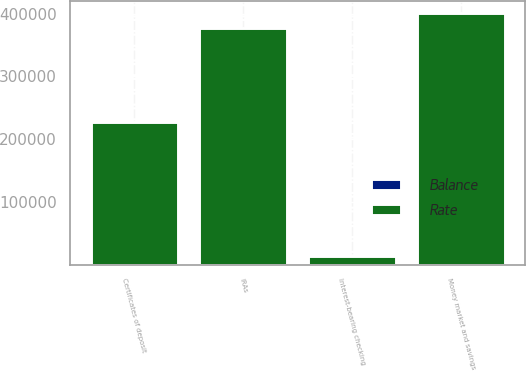<chart> <loc_0><loc_0><loc_500><loc_500><stacked_bar_chart><ecel><fcel>Money market and savings<fcel>Interest-bearing checking<fcel>IRAs<fcel>Certificates of deposit<nl><fcel>Rate<fcel>400920<fcel>13677<fcel>377973<fcel>227094<nl><fcel>Balance<fcel>0.5<fcel>0.61<fcel>1.02<fcel>1.86<nl></chart> 